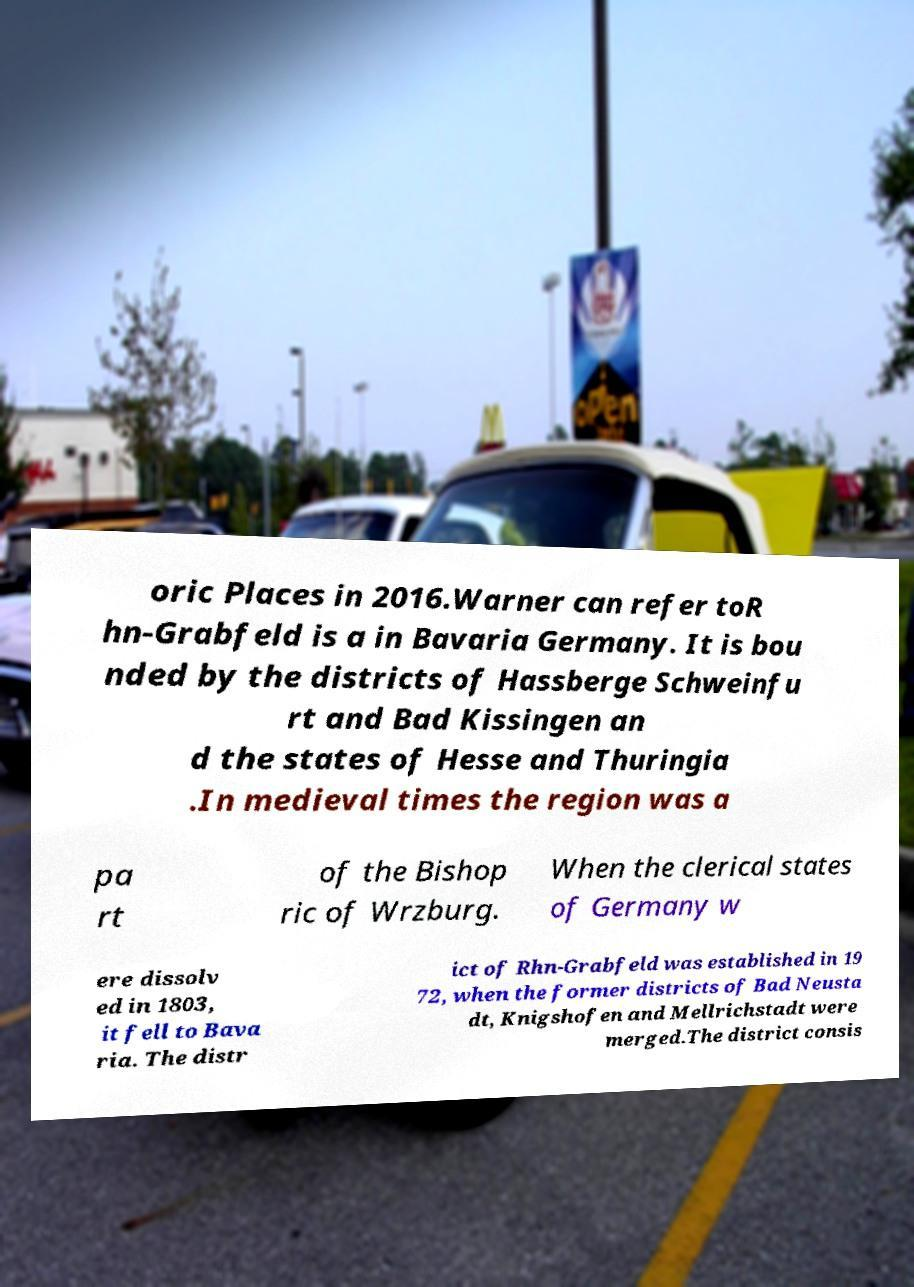Could you assist in decoding the text presented in this image and type it out clearly? oric Places in 2016.Warner can refer toR hn-Grabfeld is a in Bavaria Germany. It is bou nded by the districts of Hassberge Schweinfu rt and Bad Kissingen an d the states of Hesse and Thuringia .In medieval times the region was a pa rt of the Bishop ric of Wrzburg. When the clerical states of Germany w ere dissolv ed in 1803, it fell to Bava ria. The distr ict of Rhn-Grabfeld was established in 19 72, when the former districts of Bad Neusta dt, Knigshofen and Mellrichstadt were merged.The district consis 